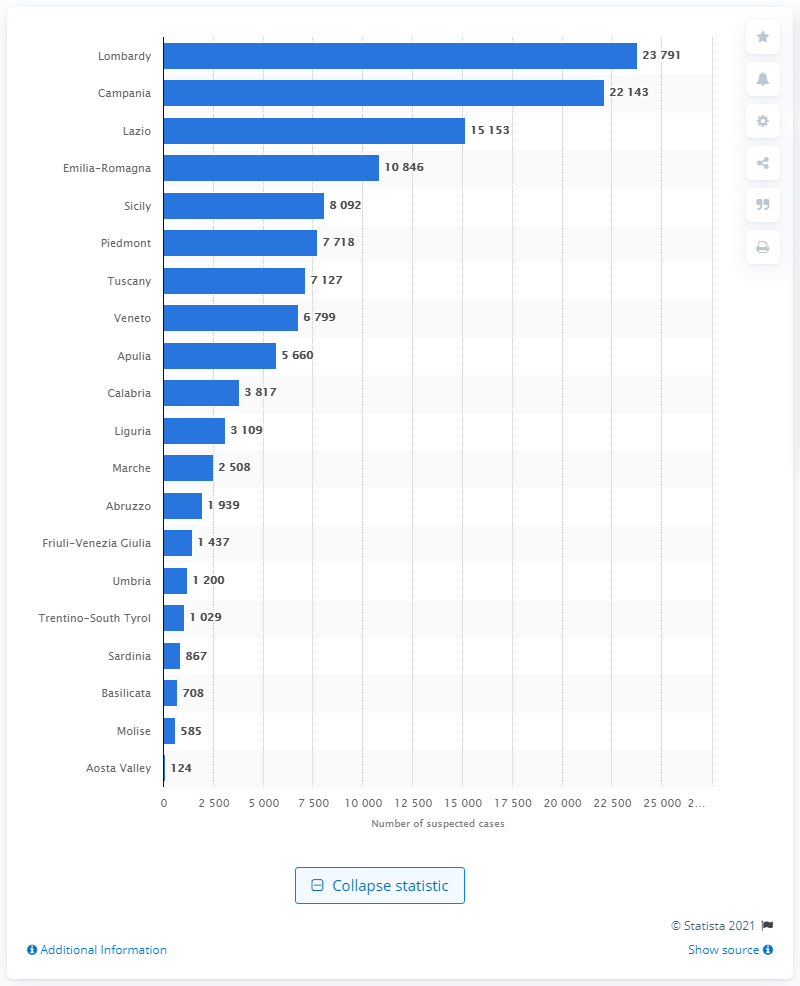How does the number of suspected cases in Sicily compare to that in Piedmont? Sicily reported 8,092 suspected financial operations in 2019, which is slightly more than Piedmont's 7,718 cases as depicted in the image. 